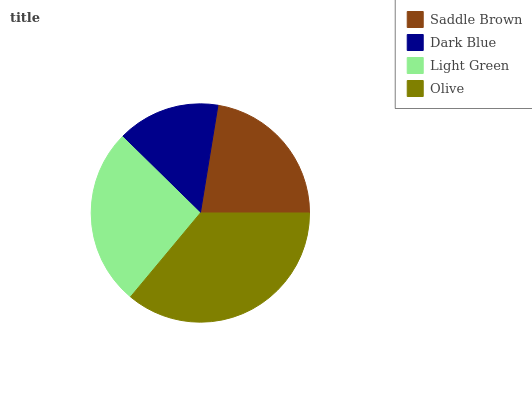Is Dark Blue the minimum?
Answer yes or no. Yes. Is Olive the maximum?
Answer yes or no. Yes. Is Light Green the minimum?
Answer yes or no. No. Is Light Green the maximum?
Answer yes or no. No. Is Light Green greater than Dark Blue?
Answer yes or no. Yes. Is Dark Blue less than Light Green?
Answer yes or no. Yes. Is Dark Blue greater than Light Green?
Answer yes or no. No. Is Light Green less than Dark Blue?
Answer yes or no. No. Is Light Green the high median?
Answer yes or no. Yes. Is Saddle Brown the low median?
Answer yes or no. Yes. Is Olive the high median?
Answer yes or no. No. Is Light Green the low median?
Answer yes or no. No. 